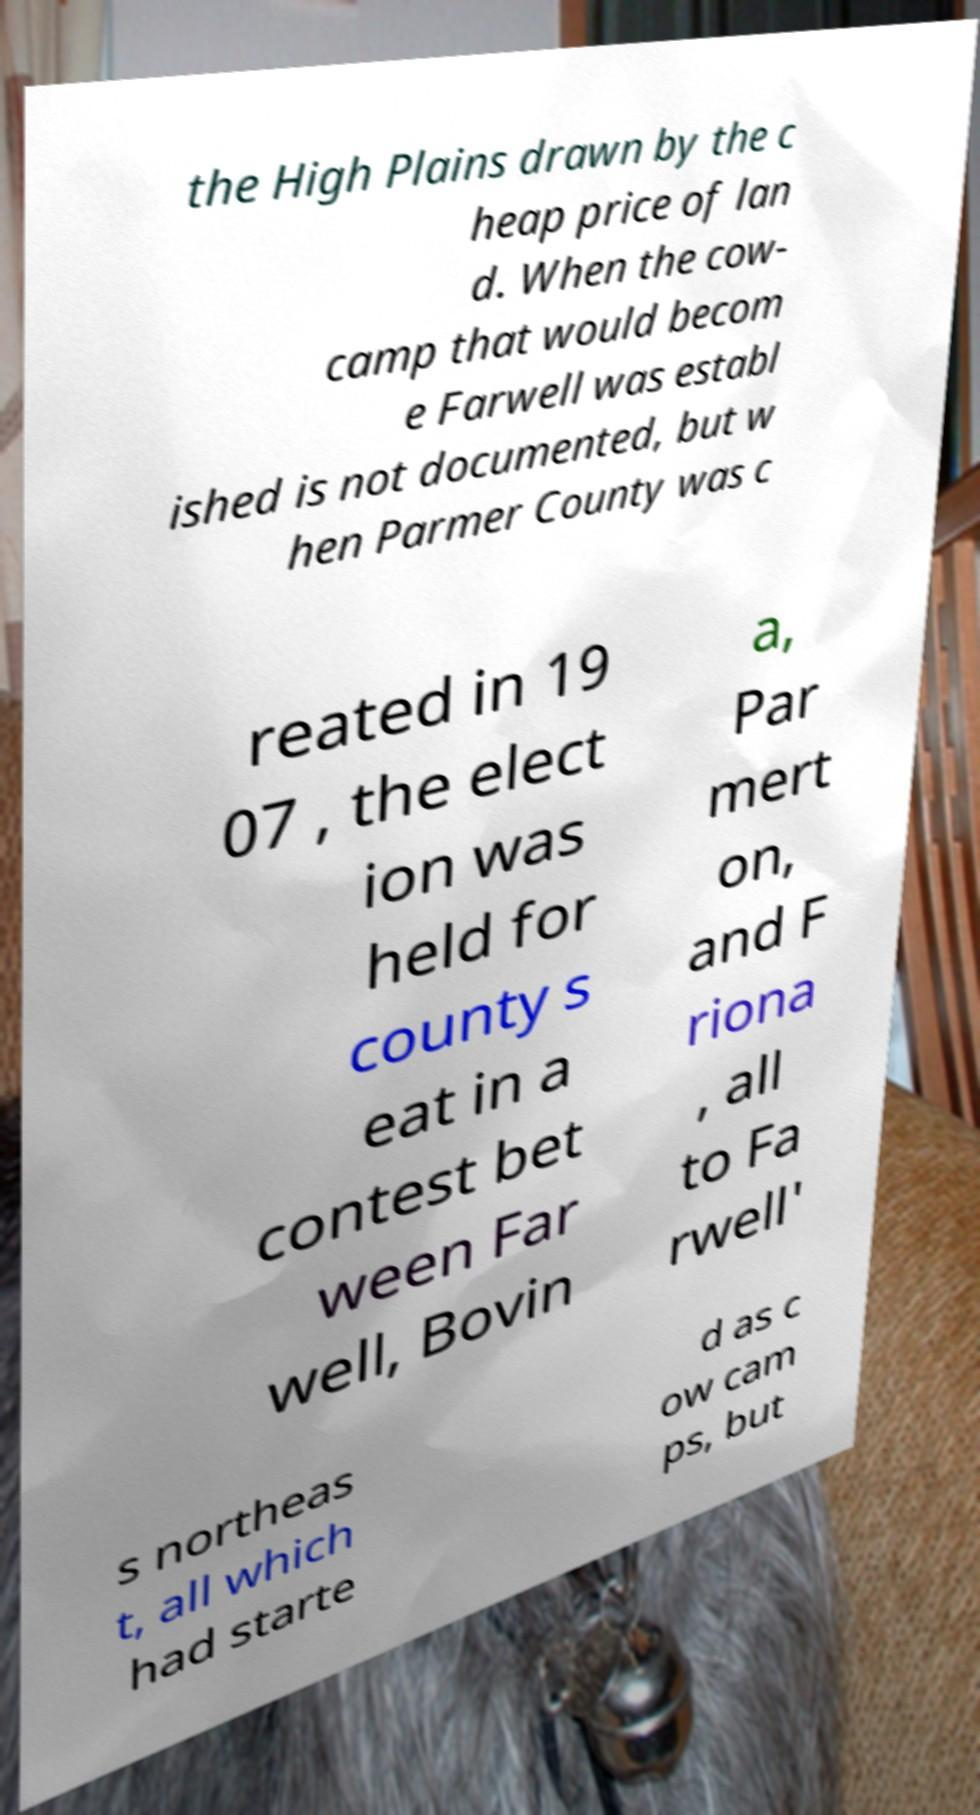Can you accurately transcribe the text from the provided image for me? the High Plains drawn by the c heap price of lan d. When the cow- camp that would becom e Farwell was establ ished is not documented, but w hen Parmer County was c reated in 19 07 , the elect ion was held for county s eat in a contest bet ween Far well, Bovin a, Par mert on, and F riona , all to Fa rwell' s northeas t, all which had starte d as c ow cam ps, but 